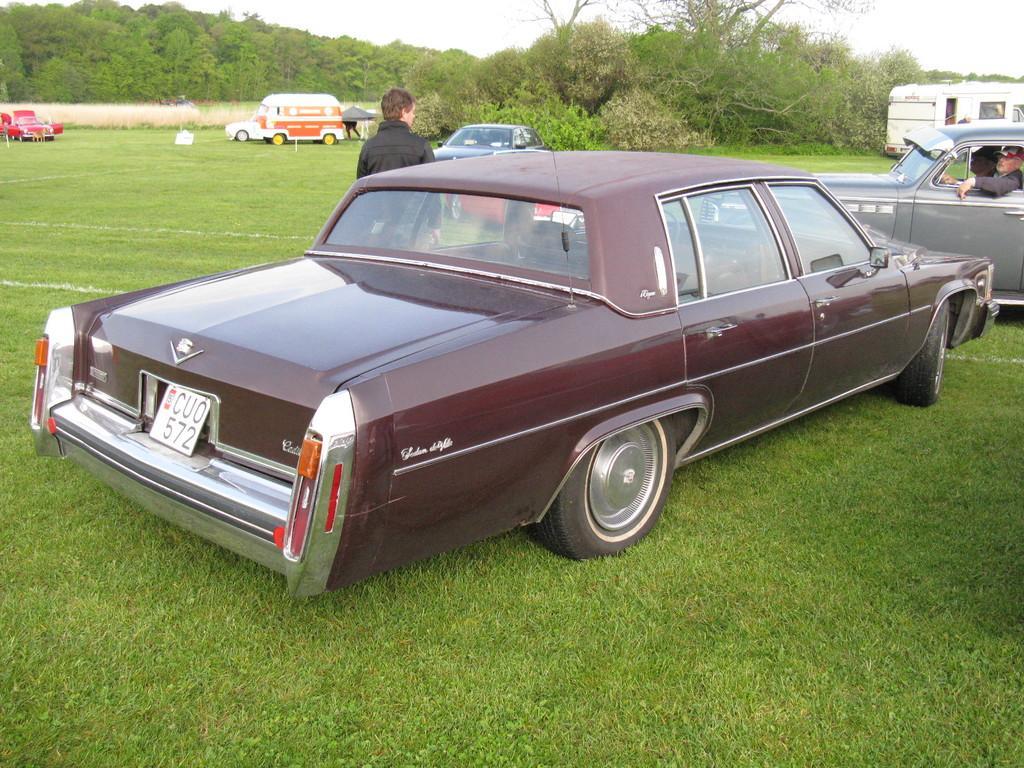Can you describe this image briefly? In this image I see a maroon colored car and there is a man over here and there is another car in which there are 2 persons and In the background I see 2 more cars, plants, grass and I see another van over here and I see the trees and the sky. 